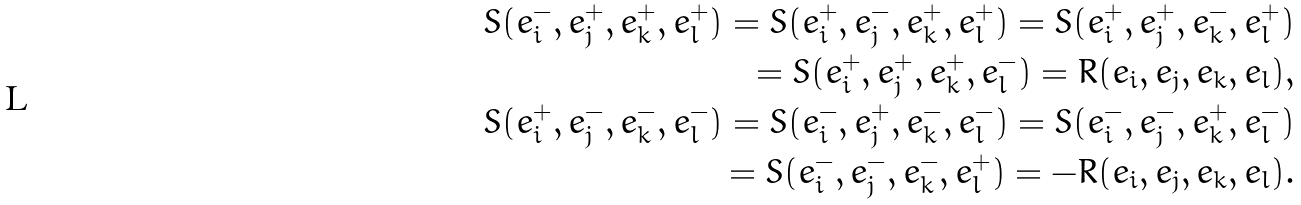<formula> <loc_0><loc_0><loc_500><loc_500>S ( e _ { i } ^ { - } , e _ { j } ^ { + } , e _ { k } ^ { + } , e _ { l } ^ { + } ) = S ( e _ { i } ^ { + } , e _ { j } ^ { - } , e _ { k } ^ { + } , e _ { l } ^ { + } ) = S ( e _ { i } ^ { + } , e _ { j } ^ { + } , e _ { k } ^ { - } , e _ { l } ^ { + } ) \\ = S ( e _ { i } ^ { + } , e _ { j } ^ { + } , e _ { k } ^ { + } , e _ { l } ^ { - } ) = R ( e _ { i } , e _ { j } , e _ { k } , e _ { l } ) , \\ S ( e _ { i } ^ { + } , e _ { j } ^ { - } , e _ { k } ^ { - } , e _ { l } ^ { - } ) = S ( e _ { i } ^ { - } , e _ { j } ^ { + } , e _ { k } ^ { - } , e _ { l } ^ { - } ) = S ( e _ { i } ^ { - } , e _ { j } ^ { - } , e _ { k } ^ { + } , e _ { l } ^ { - } ) \\ = S ( e _ { i } ^ { - } , e _ { j } ^ { - } , e _ { k } ^ { - } , e _ { l } ^ { + } ) = - R ( e _ { i } , e _ { j } , e _ { k } , e _ { l } ) .</formula> 